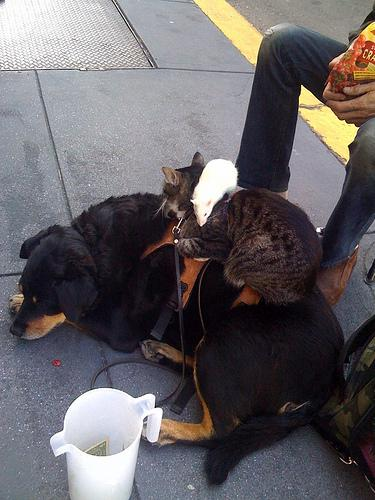Which mammal will disturb more species with it's movement? dog 